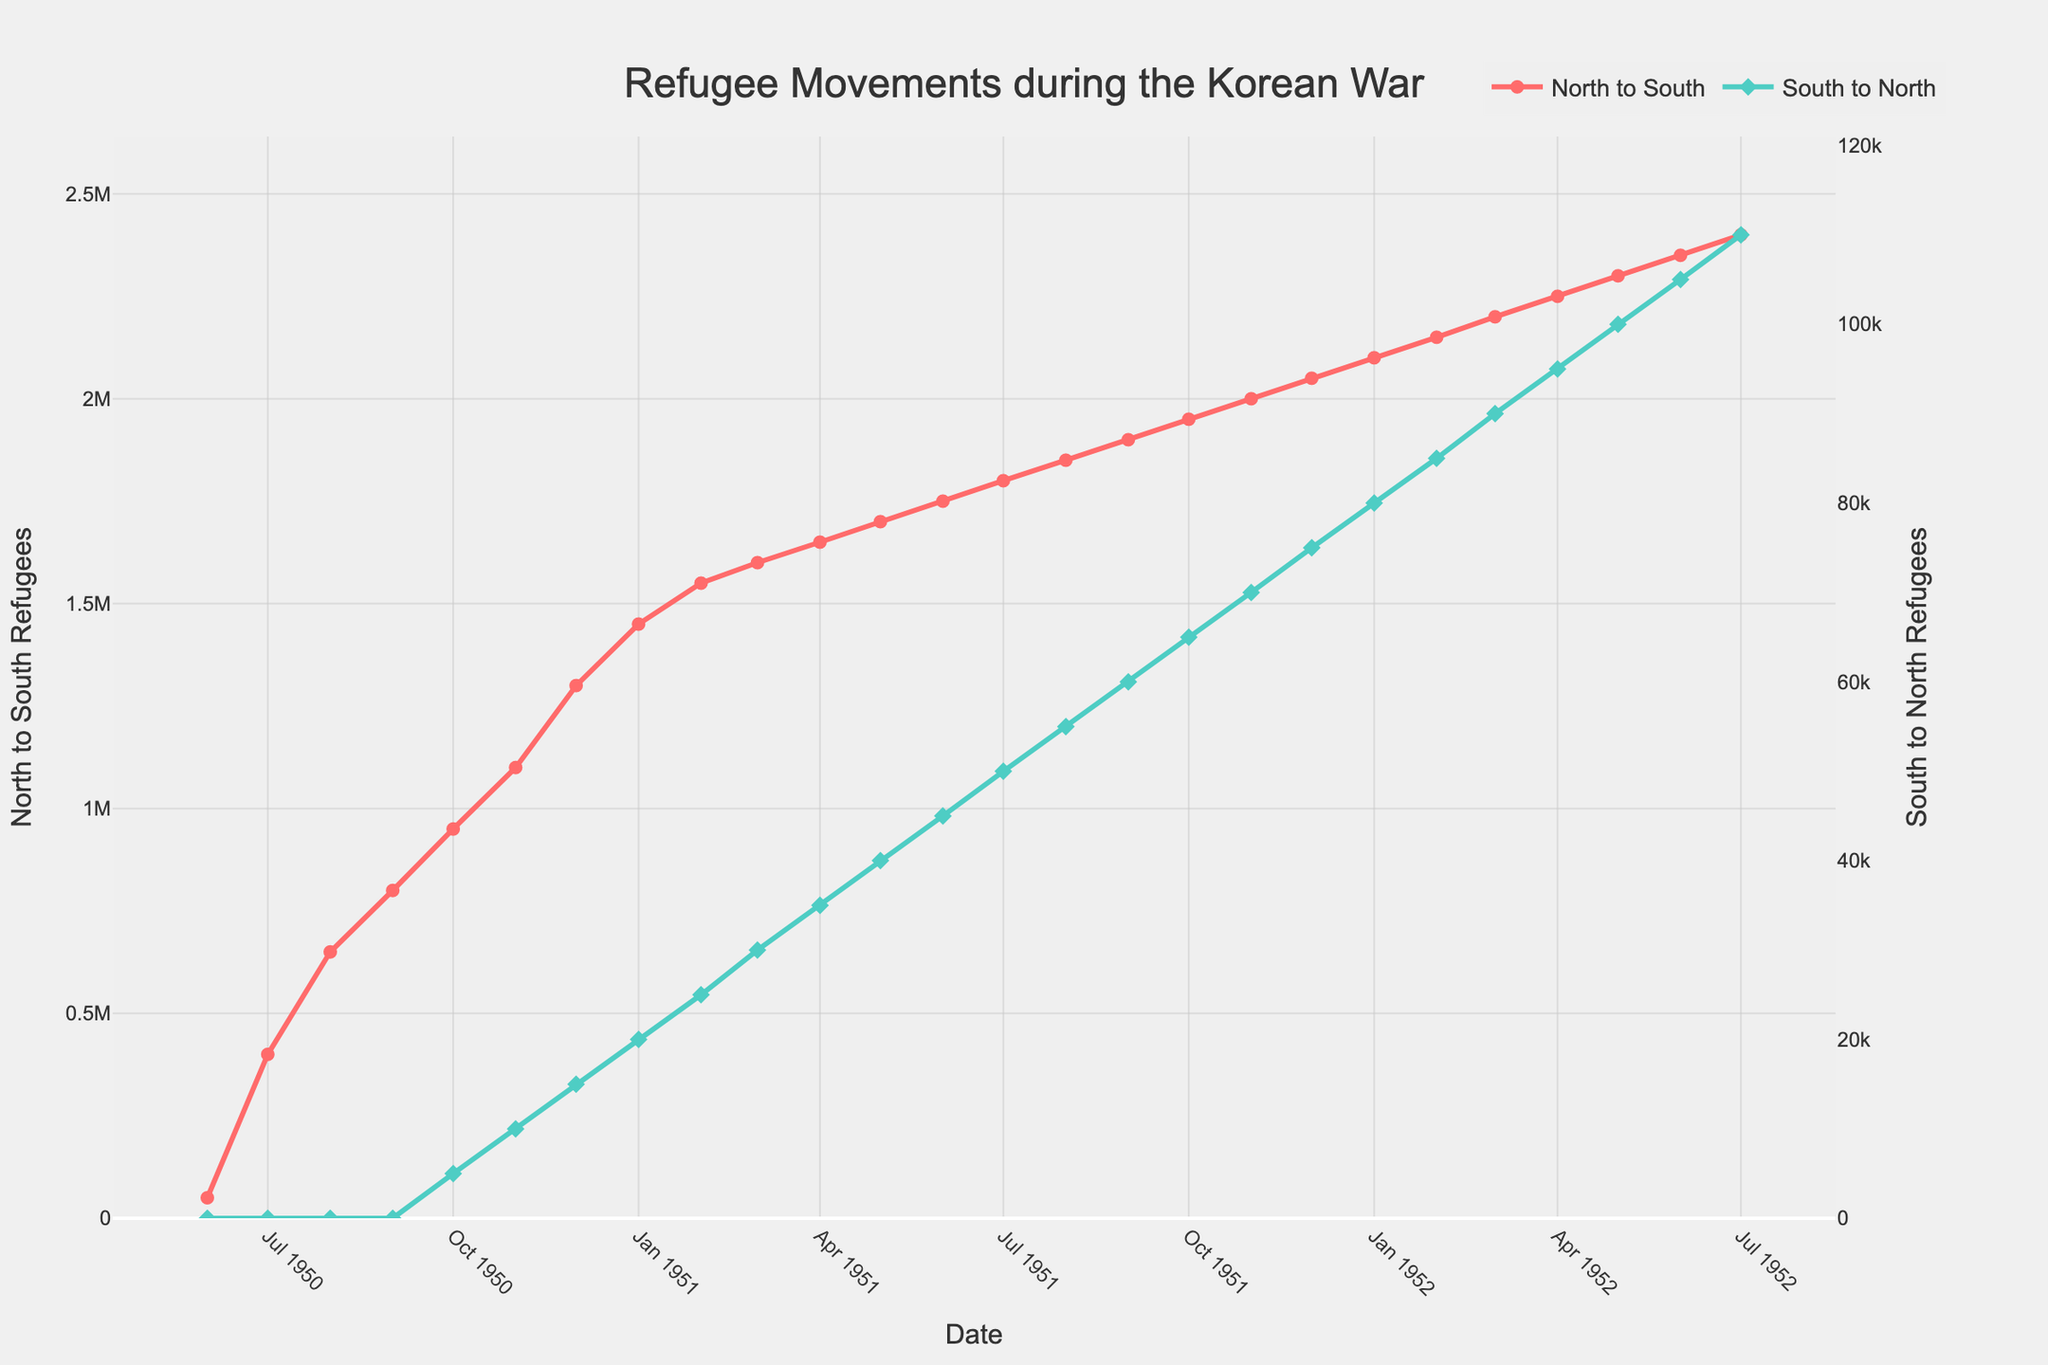What is the highest number of refugees moving from North to South? To find the highest number of refugees moving from North to South, we look at the y-values of the red line representing "North to South" refugees. The peak value appears in July 1952, which is 2,400,000.
Answer: 2,400,000 Which direction had more refugees moving in November 1950? In November 1950, we compare the values for "North to South" and "South to North." "North to South" had 1,100,000 refugees, while "South to North" had 10,000. Clearly, more refugees moved from North to South.
Answer: North to South What is the difference in the number of refugees moving from North to South between December 1950 and December 1951? First, we find the values for December 1950 and December 1951, which are 1,300,000 and 2,050,000 respectively. The difference is 2,050,000 - 1,300,000 = 750,000.
Answer: 750,000 How many times did the number of "South to North" refugees increase from July 1950 to July 1952? In July 1950, there were 0 refugees moving from South to North. By July 1952, the number increased to 110,000. To calculate the times of increase starting from zero is not feasible (since zero as the initial value doesn't allow for a multiplication factor), but it is evident that it grew from 0 to 110,000.
Answer: From 0 to 110,000 What is the average number of refugees moving from South to North across all months shown? To calculate the average, sum up the "South to North" values for all months and divide by the number of months. (0 + 0 + 0 + 0 + 5,000 + 10,000 + 15,000 + 20,000 + 25,000 + 30,000 + 35,000 + 40,000 + 45,000 + 50,000 + 55,000 + 60,000 + 65,000 + 70,000 + 75,000 + 80,000 + 85,000 + 90,000 + 95,000 + 100,000 + 105,000 + 110,000) / 26 = 1,105,000 / 26 ≈ 42,500
Answer: 42,500 Between which two consecutive months did the "North to South" refugee movements increase the most? Looking at the red line peaks, the largest increase occurs between July 1950 (400,000) and August 1950 (650,000). The increase is 650,000 - 400,000 = 250,000.
Answer: July 1950 to August 1950 When did the "South to North" refugee number first go above 50,000? We look for the first instance where the green line goes above 50,000. This happens in July 1951, where the number is exactly 50,000, so it exceeds this value in August 1951.
Answer: August 1951 